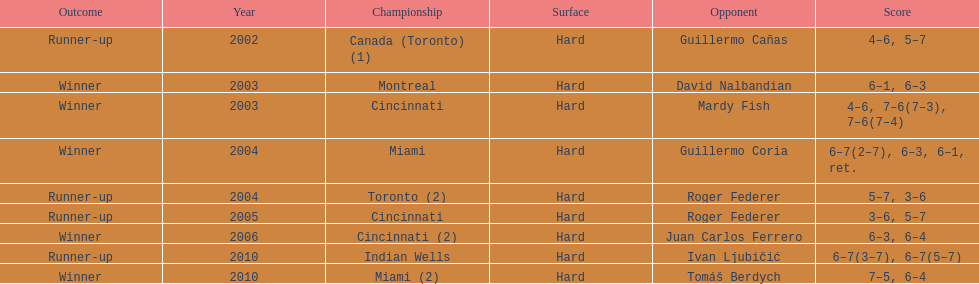How many times were roddick's opponents not from the usa? 8. 